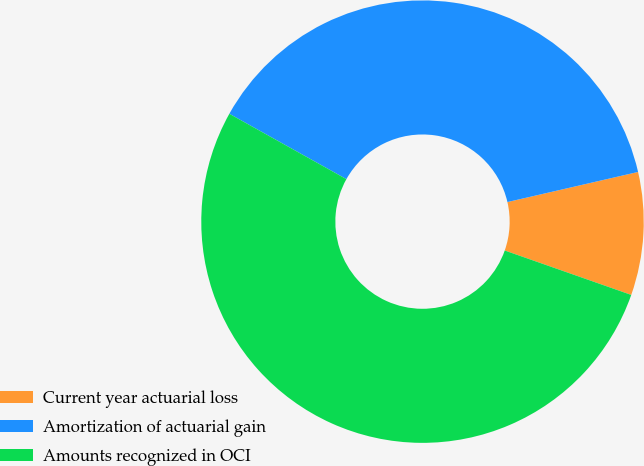Convert chart to OTSL. <chart><loc_0><loc_0><loc_500><loc_500><pie_chart><fcel>Current year actuarial loss<fcel>Amortization of actuarial gain<fcel>Amounts recognized in OCI<nl><fcel>8.98%<fcel>38.29%<fcel>52.73%<nl></chart> 